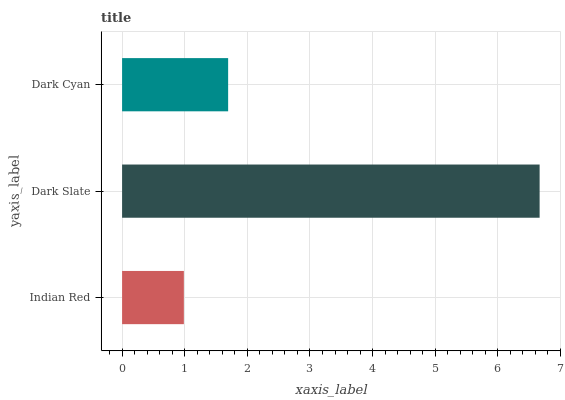Is Indian Red the minimum?
Answer yes or no. Yes. Is Dark Slate the maximum?
Answer yes or no. Yes. Is Dark Cyan the minimum?
Answer yes or no. No. Is Dark Cyan the maximum?
Answer yes or no. No. Is Dark Slate greater than Dark Cyan?
Answer yes or no. Yes. Is Dark Cyan less than Dark Slate?
Answer yes or no. Yes. Is Dark Cyan greater than Dark Slate?
Answer yes or no. No. Is Dark Slate less than Dark Cyan?
Answer yes or no. No. Is Dark Cyan the high median?
Answer yes or no. Yes. Is Dark Cyan the low median?
Answer yes or no. Yes. Is Dark Slate the high median?
Answer yes or no. No. Is Dark Slate the low median?
Answer yes or no. No. 